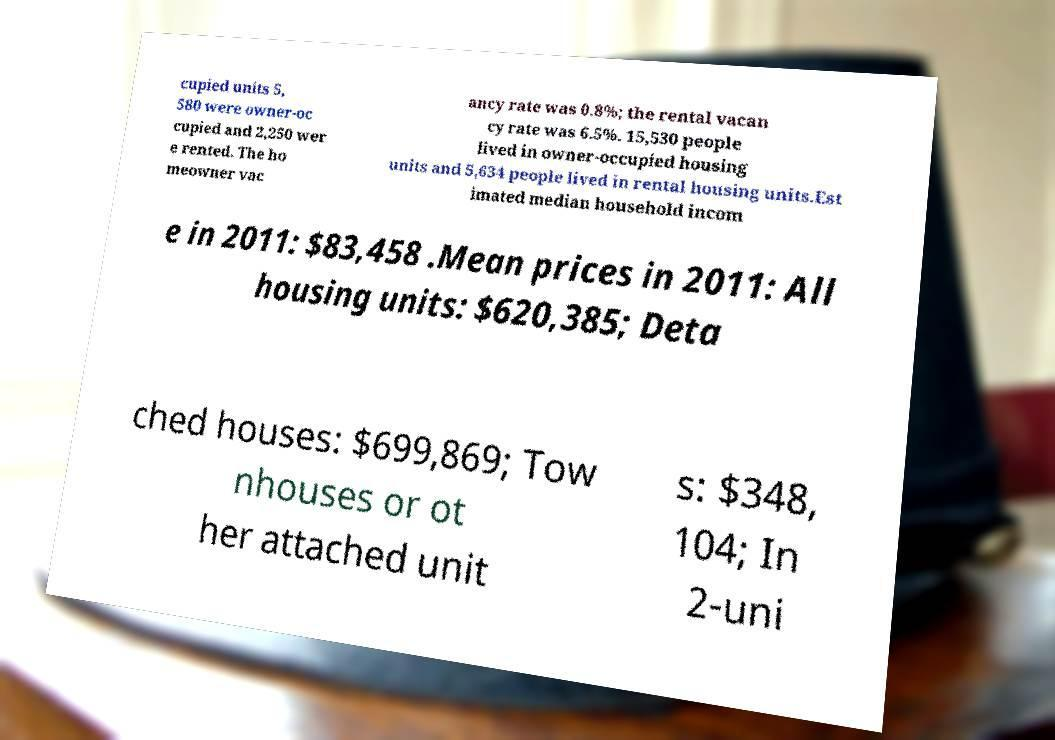Could you assist in decoding the text presented in this image and type it out clearly? cupied units 5, 580 were owner-oc cupied and 2,250 wer e rented. The ho meowner vac ancy rate was 0.8%; the rental vacan cy rate was 6.5%. 15,530 people lived in owner-occupied housing units and 5,634 people lived in rental housing units.Est imated median household incom e in 2011: $83,458 .Mean prices in 2011: All housing units: $620,385; Deta ched houses: $699,869; Tow nhouses or ot her attached unit s: $348, 104; In 2-uni 